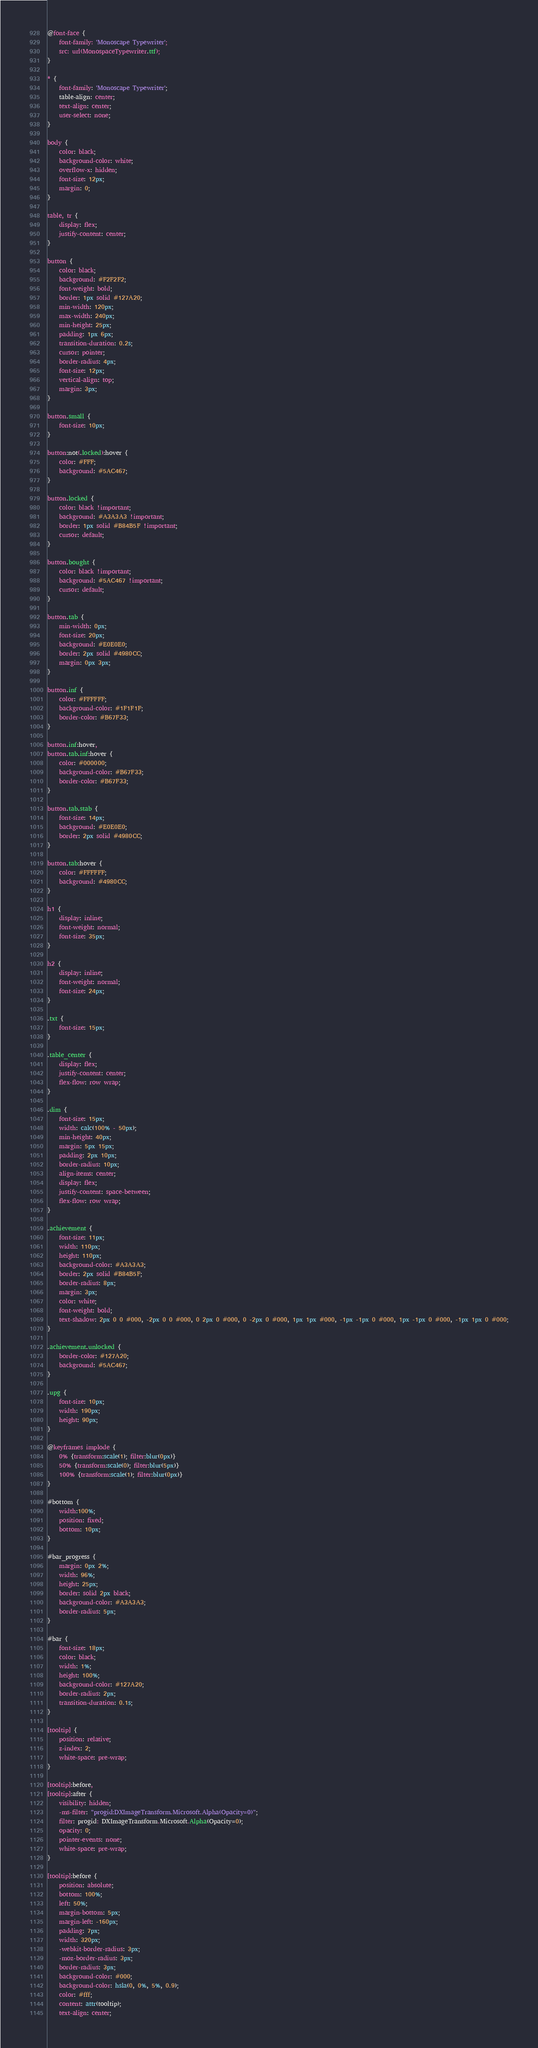Convert code to text. <code><loc_0><loc_0><loc_500><loc_500><_CSS_>@font-face {
	font-family: 'Monoscape Typewriter';
	src: url(MonospaceTypewriter.ttf);
}

* {
    font-family: 'Monoscape Typewriter';
    table-align: center;
	text-align: center;
	user-select: none;
}

body {
    color: black;
    background-color: white;
	overflow-x: hidden;
	font-size: 12px;
	margin: 0;
}

table, tr {
    display: flex;
    justify-content: center;
}

button {
	color: black;
    background: #F2F2F2;
    font-weight: bold;
    border: 1px solid #127A20;
    min-width: 120px;
	max-width: 240px;
	min-height: 25px;
	padding: 1px 6px;
    transition-duration: 0.2s;
    cursor: pointer;
    border-radius: 4px;
    font-size: 12px;
    vertical-align: top;
	margin: 3px;
}

button.small {
	font-size: 10px;
}

button:not(.locked):hover {
    color: #FFF;
    background: #5AC467;
}

button.locked {
	color: black !important;
    background: #A3A3A3 !important;
    border: 1px solid #B84B5F !important;
	cursor: default;
}

button.bought {
	color: black !important;
    background: #5AC467 !important;
	cursor: default;
}

button.tab {
	min-width: 0px;
	font-size: 20px;
	background: #E0E0E0;
    border: 2px solid #4980CC;
	margin: 0px 3px;
}

button.inf {
	color: #FFFFFF;
    background-color: #1F1F1F;
    border-color: #B67F33;
}

button.inf:hover,
button.tab.inf:hover {
	color: #000000;
	background-color: #B67F33;
	border-color: #B67F33;
}

button.tab.stab {
	font-size: 14px;
	background: #E0E0E0;
    border: 2px solid #4980CC;
}

button.tab:hover {
	color: #FFFFFF;
    background: #4980CC;
}

h1 {
    display: inline;
	font-weight: normal;
    font-size: 35px;
}

h2 {
	display: inline;
	font-weight: normal;
    font-size: 24px;
}

.txt {
	font-size: 15px;
}

.table_center {
    display: flex;
    justify-content: center;
    flex-flow: row wrap;
}

.dim {
	font-size: 15px;
	width: calc(100% - 50px);
	min-height: 40px;
	margin: 5px 15px;
	padding: 2px 10px;
	border-radius: 10px;
	align-items: center;
	display: flex;
    justify-content: space-between;
    flex-flow: row wrap;
}

.achievement {
	font-size: 11px;
	width: 110px;
	height: 110px;
	background-color: #A3A3A3;
    border: 2px solid #B84B5F;
	border-radius: 8px;
	margin: 3px;
	color: white;
	font-weight: bold;
	text-shadow: 2px 0 0 #000, -2px 0 0 #000, 0 2px 0 #000, 0 -2px 0 #000, 1px 1px #000, -1px -1px 0 #000, 1px -1px 0 #000, -1px 1px 0 #000;
}

.achievement.unlocked {
	border-color: #127A20;
    background: #5AC467;
}

.upg {
	font-size: 10px;
	width: 190px;
	height: 90px;
}

@keyframes implode {
    0% {transform:scale(1); filter:blur(0px)}
    50% {transform:scale(0); filter:blur(5px)}
    100% {transform:scale(1); filter:blur(0px)}
}

#bottom {
	width:100%;
	position: fixed;
	bottom: 10px;
}

#bar_progress {
	margin: 0px 2%;
	width: 96%;
	height: 25px;
	border: solid 2px black;
	background-color: #A3A3A3;
	border-radius: 5px;
}

#bar {
	font-size: 18px;
	color: black;
	width: 1%;
	height: 100%;
	background-color: #127A20;
	border-radius: 2px;
	transition-duration: 0.1s;
}

[tooltip] {
	position: relative;
	z-index: 2;
	white-space: pre-wrap;
}

[tooltip]:before,
[tooltip]:after {
	visibility: hidden;
	-ms-filter: "progid:DXImageTransform.Microsoft.Alpha(Opacity=0)";
	filter: progid: DXImageTransform.Microsoft.Alpha(Opacity=0);
	opacity: 0;
	pointer-events: none;
	white-space: pre-wrap;
}

[tooltip]:before {
	position: absolute;
	bottom: 100%;
	left: 50%;
	margin-bottom: 5px;
	margin-left: -160px;
	padding: 7px;
	width: 320px;
	-webkit-border-radius: 3px;
	-moz-border-radius: 3px;
	border-radius: 3px;
	background-color: #000;
	background-color: hsla(0, 0%, 5%, 0.9);
	color: #fff;
	content: attr(tooltip);
	text-align: center;</code> 